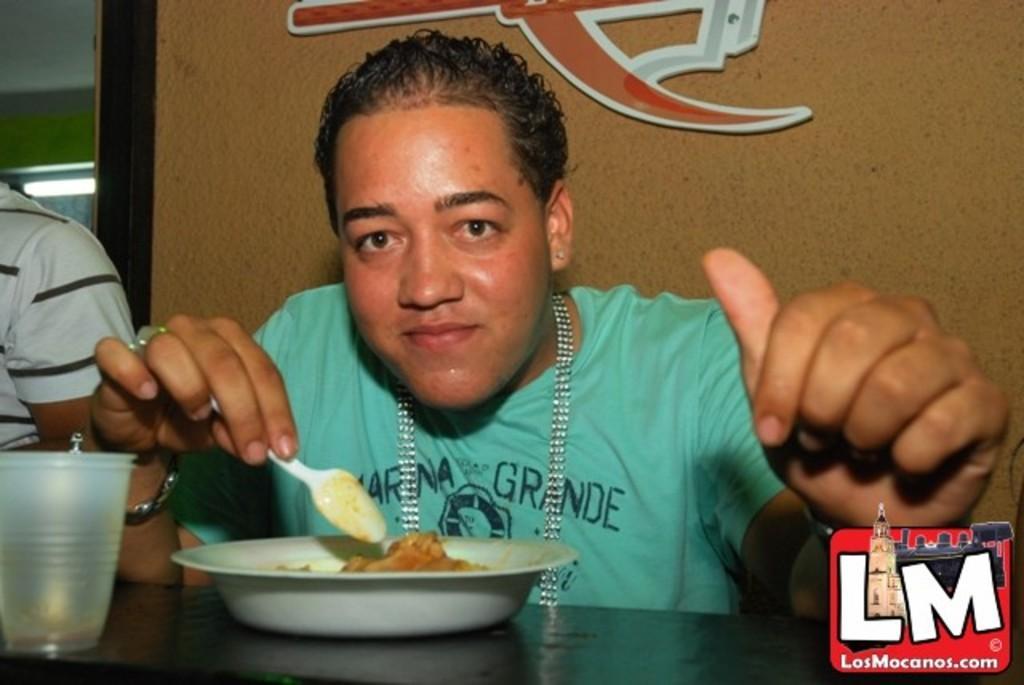Describe this image in one or two sentences. In the image we can see two people sitting and the right side person is wearing a neck chain, ear studs, finger ring, bracelet and the person is holding a spoon in hand. Here we can see the table, on the table, we can see the plate and glass and we can see food item in the plate. Here we can see the wall, lights and on the bottom right we can see the watermark. 